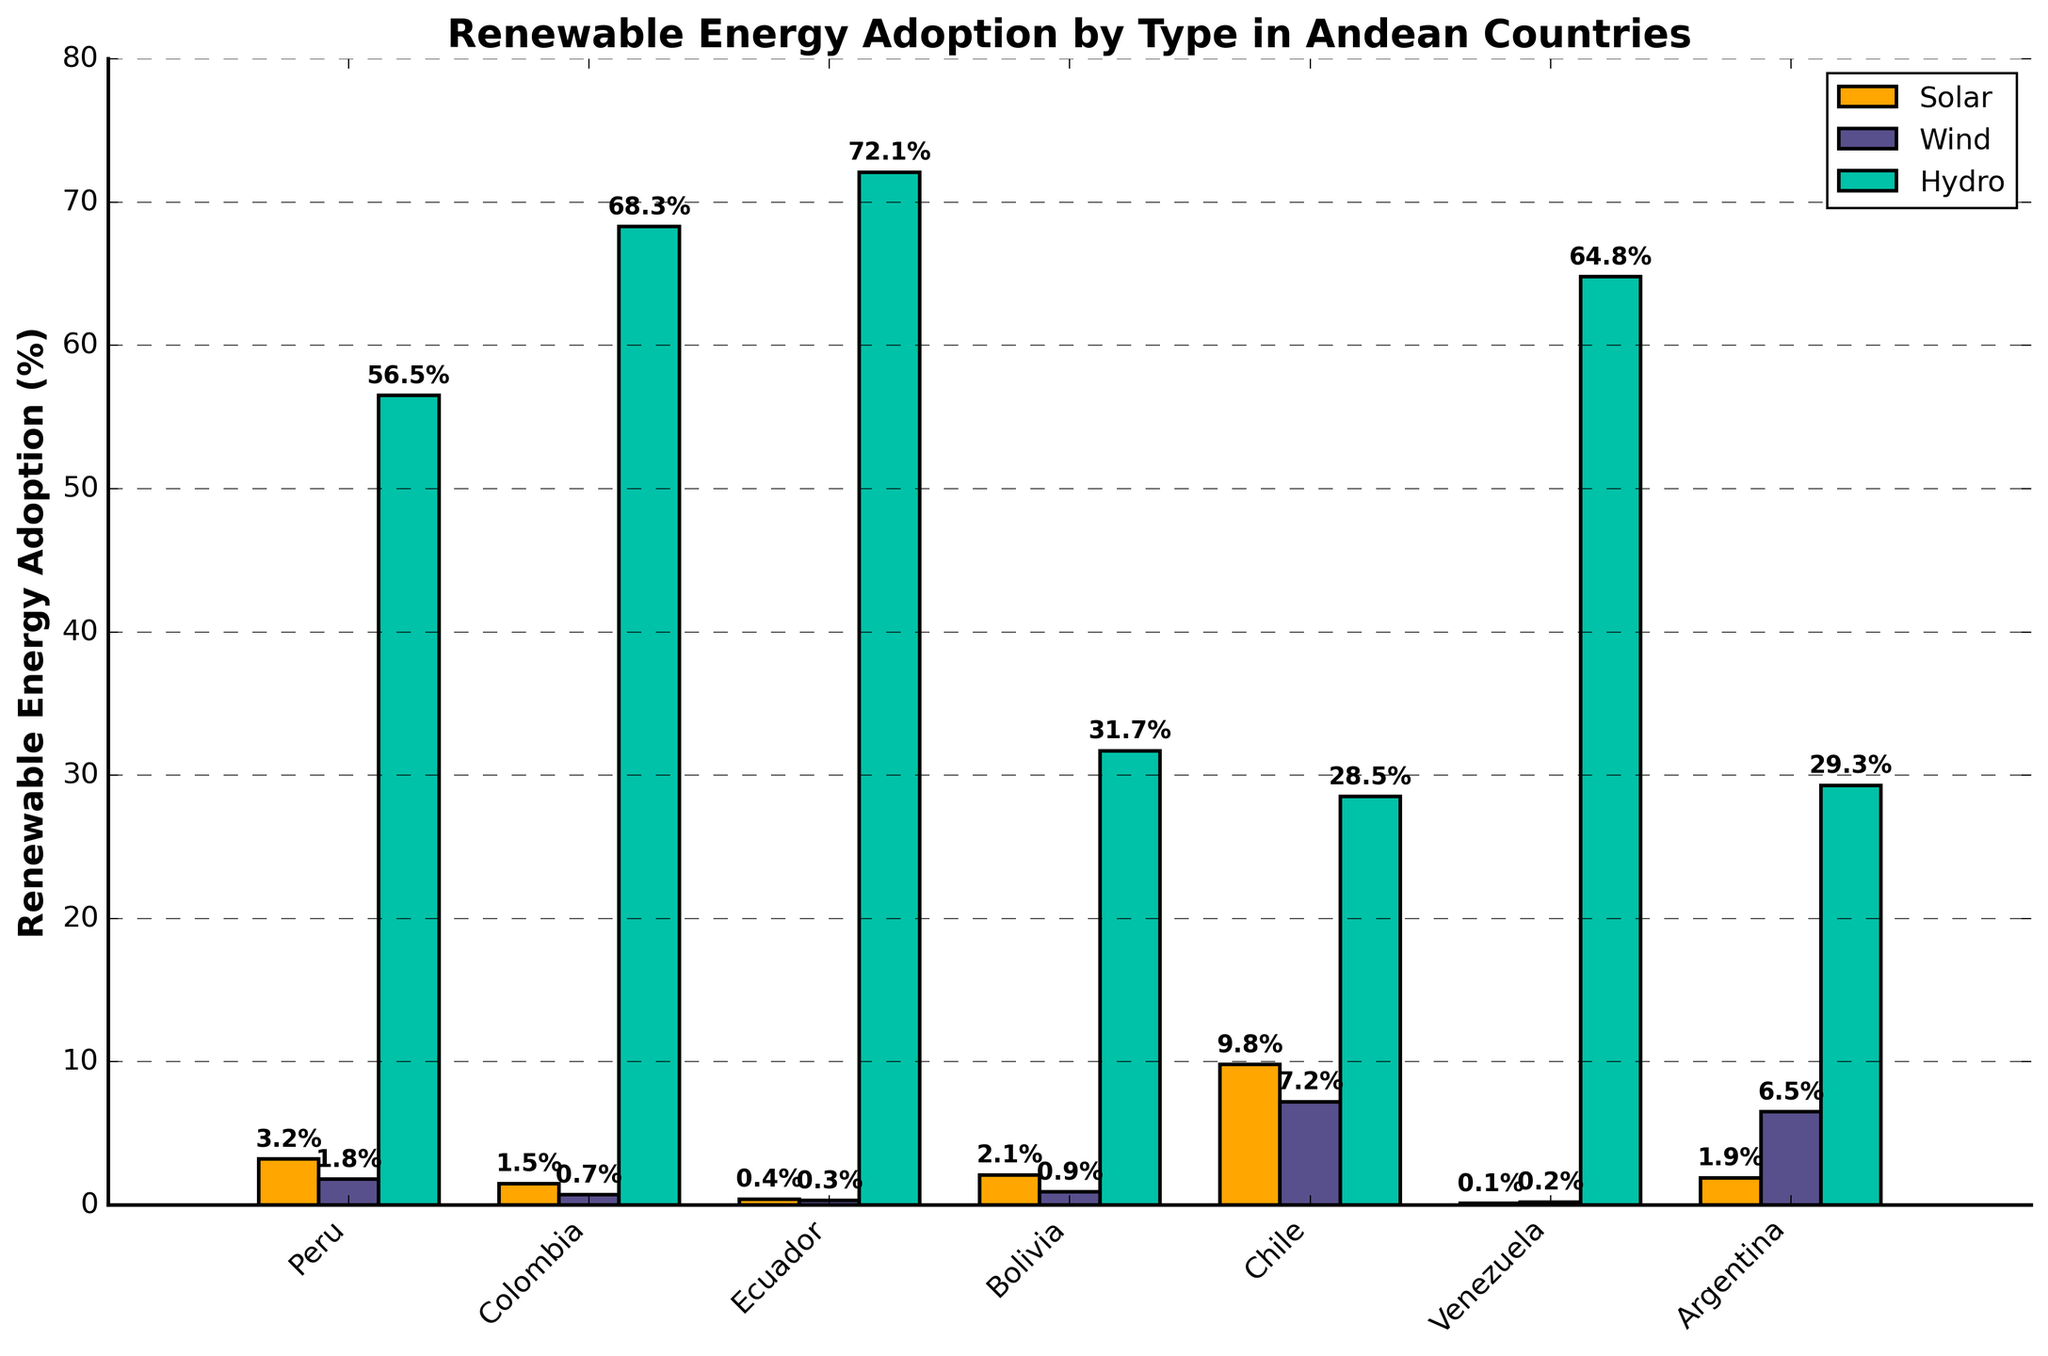What is the renewable energy type with the highest adoption percentage in Chile? By looking at the three bars representing Solar, Wind, and Hydro for Chile, the highest bar is for Solar. Therefore, Solar has the highest adoption percentage.
Answer: Solar Which country has the lowest percentage of Solar energy adoption, and what is that percentage? Comparing the heights of the Solar bars for each country, Venezuela has the lowest bar, representing 0.1%.
Answer: Venezuela, 0.1% How does the adoption of Wind energy in Argentina compare to that in Colombia? By comparing the height of the Wind bars for Argentina and Colombia, Argentina's bar is significantly higher than Colombia's, indicating higher adoption of Wind energy in Argentina (6.5%) compared to Colombia (0.7%).
Answer: Argentina has higher Wind energy adoption What is the combined adoption percentage of Solar and Wind energy in Peru? To find the combined adoption percentage, add the percentages of Solar and Wind for Peru, which are 3.2% and 1.8%, respectively. Therefore, 3.2 + 1.8 = 5%.
Answer: 5% Which country has the most balanced adoption percentages among Solar, Wind, and Hydro energies? By observing the heights of all three bars (Solar, Wind, and Hydro) for each country and comparing the relative differences, Bolivia has more balanced adoption among the three types as none of the bars are extremely different in height compared to other countries.
Answer: Bolivia Rank the countries from highest to lowest Hydro energy adoption. By comparing the heights of the Hydro bars for all countries, the ranking from highest to lowest is: Ecuador (72.1%), Colombia (68.3%), Venezuela (64.8%), Peru (56.5%), Argentina (29.3%), Chile (28.5%), Bolivia (31.7%).
Answer: Ecuador, Colombia, Venezuela, Peru, Bolivia, Argentina, Chile What is the difference in Hydro energy adoption between the top two countries? The highest Hydro adoption is in Ecuador (72.1%) and the second highest is in Colombia (68.3%). The difference is 72.1 - 68.3 = 3.8%.
Answer: 3.8% In which country is the percentage of Solar adoption more than double the percentage of Wind adoption? By doubling the percentages of Wind adoption and comparing them to Solar percentages in each country, we find Chile (7.2% * 2 = 14.4%, Solar = 9.8%), so while close, it doesn't meet the criteria. For other countries, Solar is not more than double the Wind except marginally in Peru (1.8% * 2 = 3.6%, Solar = 3.2%). Comparing data may lead us to discarding this observation.
Answer: No country exactly fits without ambiguity in provided data What is the total adoption percentage for Solar, Wind, and Hydro energy in Venezuela? Adding the adoption percentages for Solar, Wind, and Hydro in Venezuela (0.1%, 0.2%, and 64.8% respectively), the total is 0.1 + 0.2 + 64.8 = 65.1%.
Answer: 65.1% 